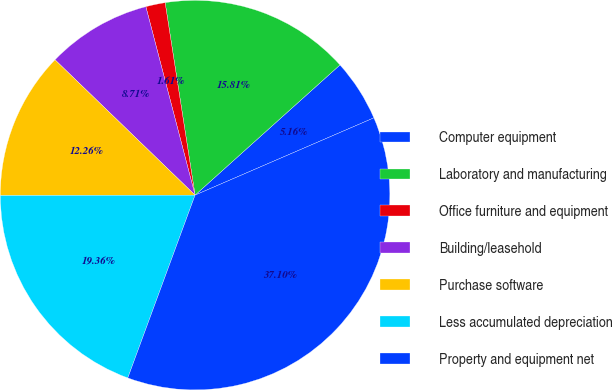Convert chart. <chart><loc_0><loc_0><loc_500><loc_500><pie_chart><fcel>Computer equipment<fcel>Laboratory and manufacturing<fcel>Office furniture and equipment<fcel>Building/leasehold<fcel>Purchase software<fcel>Less accumulated depreciation<fcel>Property and equipment net<nl><fcel>5.16%<fcel>15.81%<fcel>1.61%<fcel>8.71%<fcel>12.26%<fcel>19.36%<fcel>37.11%<nl></chart> 